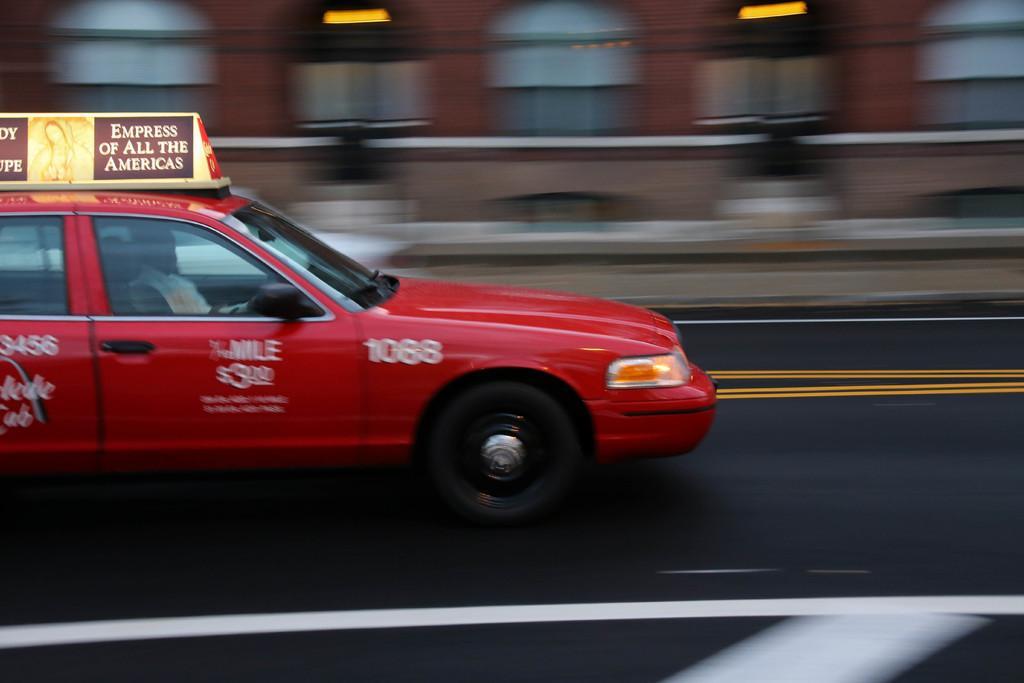Please provide a concise description of this image. In the center of the image we can see one red car on the road. In the car,we can see one person is sitting. On the car, there is a banner. In the background there is a building, windows, lights etc. 